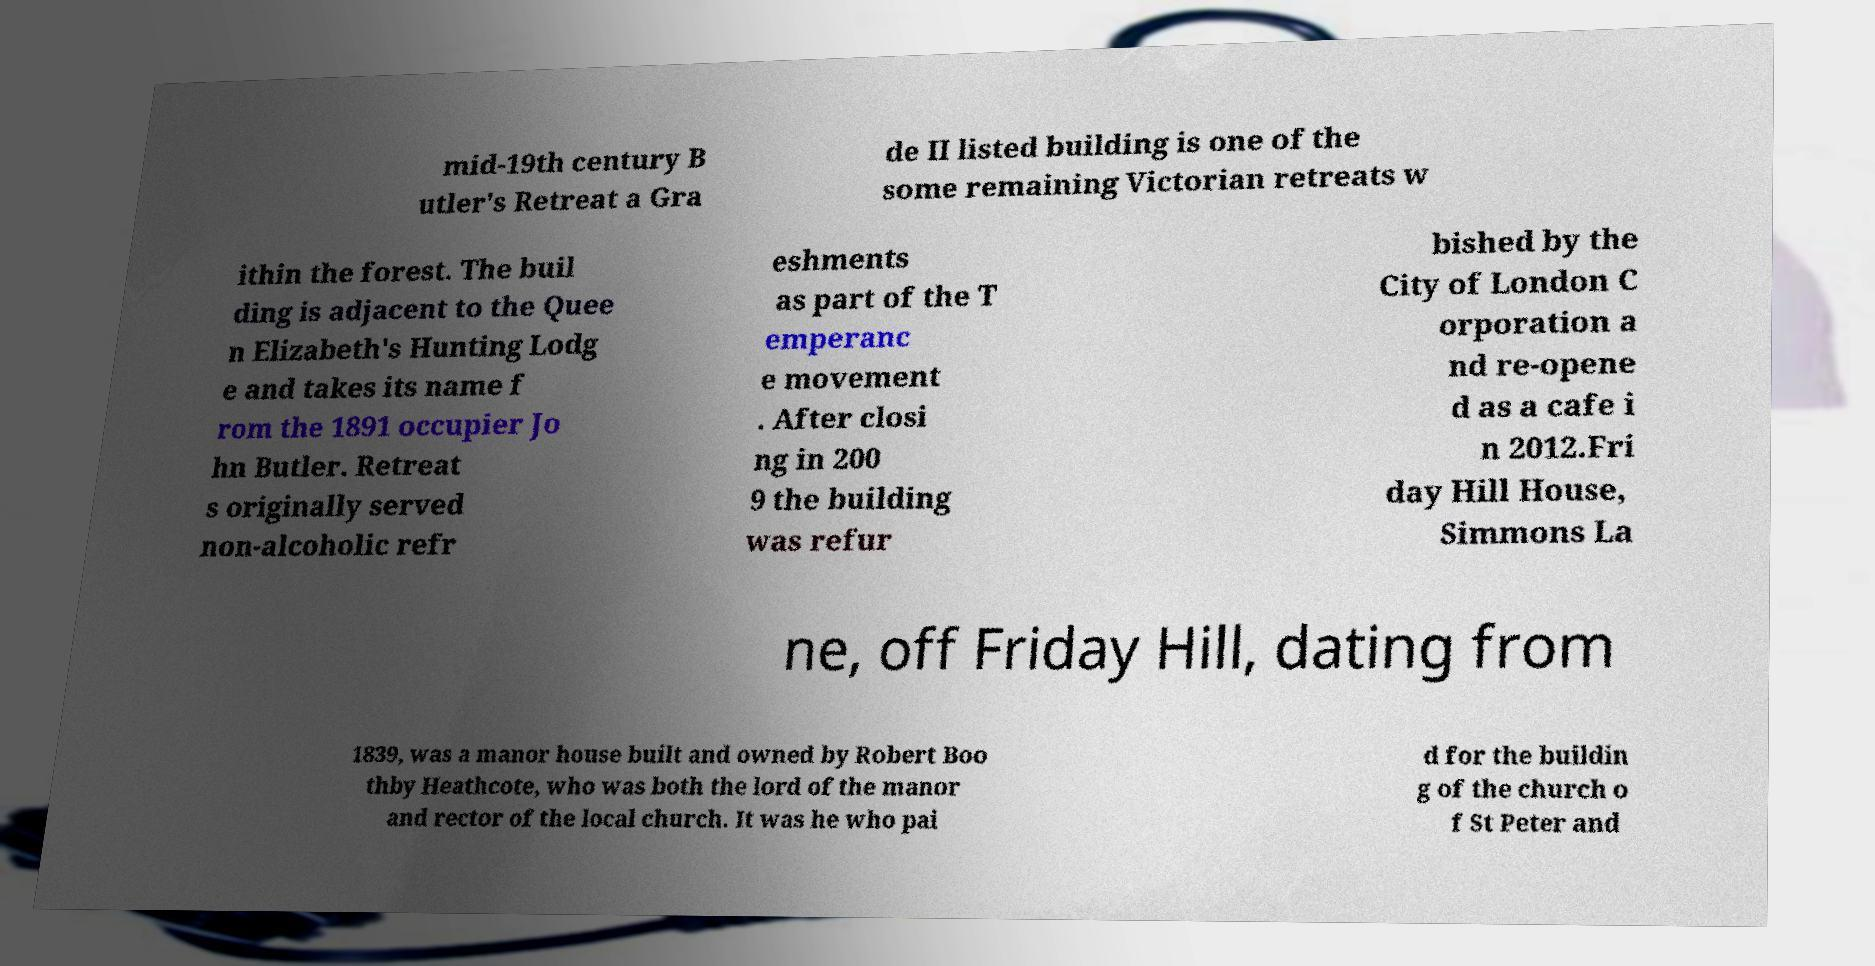Can you accurately transcribe the text from the provided image for me? mid-19th century B utler's Retreat a Gra de II listed building is one of the some remaining Victorian retreats w ithin the forest. The buil ding is adjacent to the Quee n Elizabeth's Hunting Lodg e and takes its name f rom the 1891 occupier Jo hn Butler. Retreat s originally served non-alcoholic refr eshments as part of the T emperanc e movement . After closi ng in 200 9 the building was refur bished by the City of London C orporation a nd re-opene d as a cafe i n 2012.Fri day Hill House, Simmons La ne, off Friday Hill, dating from 1839, was a manor house built and owned by Robert Boo thby Heathcote, who was both the lord of the manor and rector of the local church. It was he who pai d for the buildin g of the church o f St Peter and 